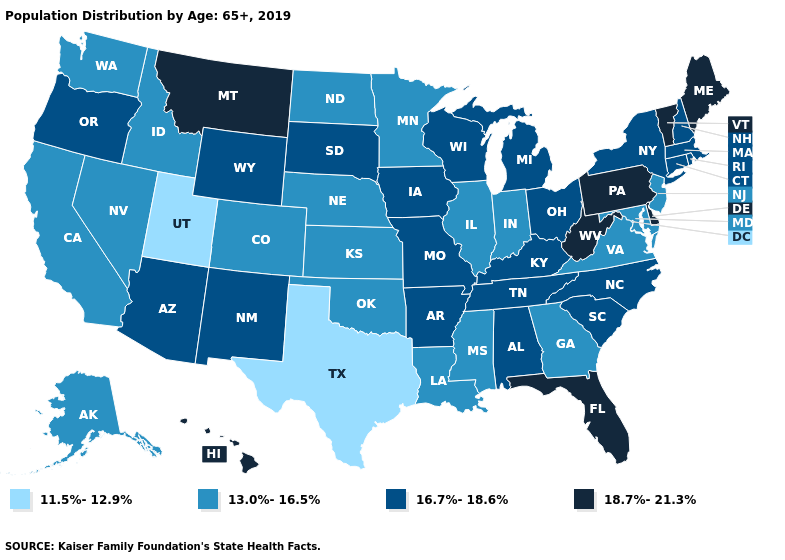What is the value of Oregon?
Write a very short answer. 16.7%-18.6%. Does the first symbol in the legend represent the smallest category?
Answer briefly. Yes. What is the value of Connecticut?
Answer briefly. 16.7%-18.6%. Which states have the lowest value in the West?
Quick response, please. Utah. Is the legend a continuous bar?
Be succinct. No. Does Texas have a lower value than West Virginia?
Concise answer only. Yes. Does the map have missing data?
Quick response, please. No. Is the legend a continuous bar?
Quick response, please. No. Does Texas have the lowest value in the USA?
Short answer required. Yes. Name the states that have a value in the range 18.7%-21.3%?
Answer briefly. Delaware, Florida, Hawaii, Maine, Montana, Pennsylvania, Vermont, West Virginia. What is the highest value in the South ?
Write a very short answer. 18.7%-21.3%. What is the value of Illinois?
Be succinct. 13.0%-16.5%. What is the value of Louisiana?
Quick response, please. 13.0%-16.5%. What is the value of Rhode Island?
Write a very short answer. 16.7%-18.6%. What is the value of Idaho?
Keep it brief. 13.0%-16.5%. 